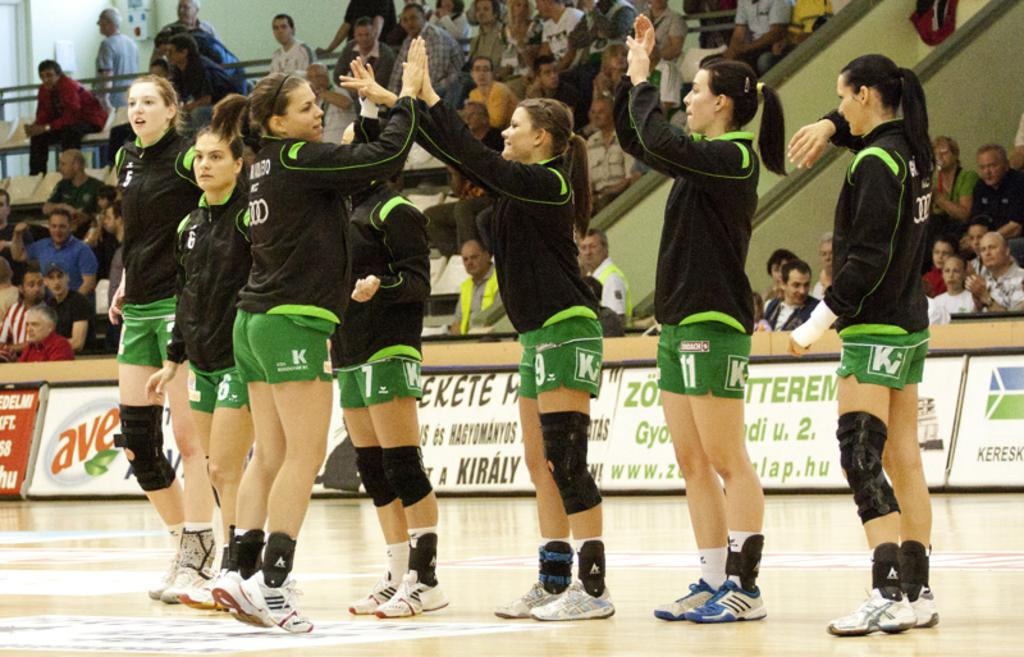<image>
Present a compact description of the photo's key features. seven women in outfits marked with a "KV" logo 